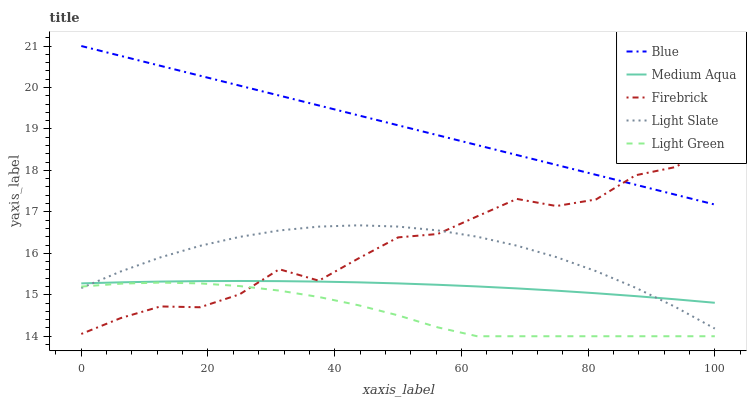Does Light Slate have the minimum area under the curve?
Answer yes or no. No. Does Light Slate have the maximum area under the curve?
Answer yes or no. No. Is Light Slate the smoothest?
Answer yes or no. No. Is Light Slate the roughest?
Answer yes or no. No. Does Light Slate have the lowest value?
Answer yes or no. No. Does Light Slate have the highest value?
Answer yes or no. No. Is Medium Aqua less than Blue?
Answer yes or no. Yes. Is Blue greater than Light Slate?
Answer yes or no. Yes. Does Medium Aqua intersect Blue?
Answer yes or no. No. 